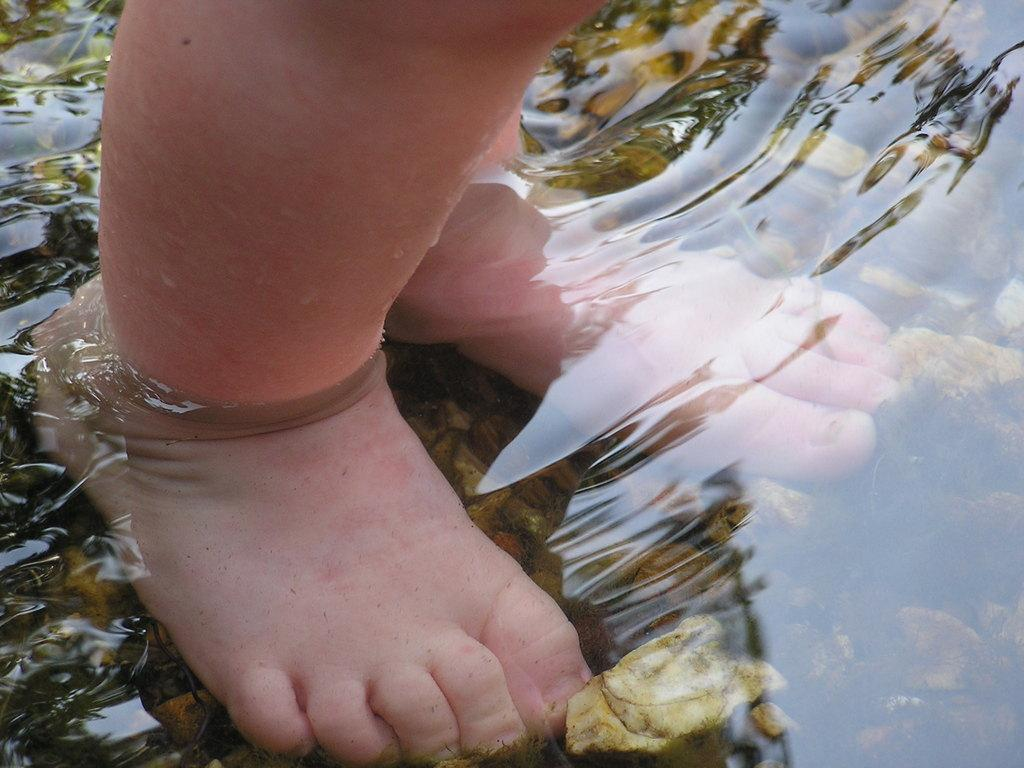What is the kid doing in the image? The kid is standing in the water. What else can be seen in the water besides the kid? There are stones in the water. What type of fog can be seen in the image? There is no fog present in the image; it features a kid standing in the water with stones. 